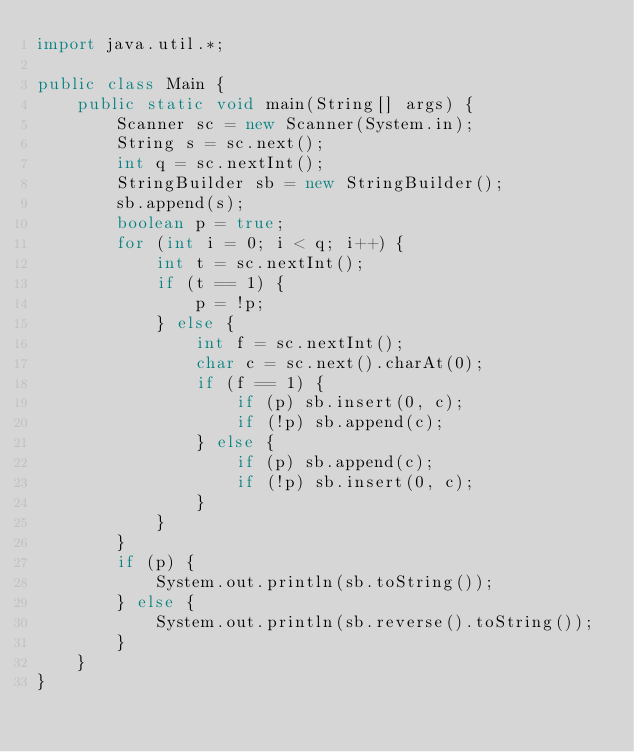<code> <loc_0><loc_0><loc_500><loc_500><_Java_>import java.util.*;

public class Main {
    public static void main(String[] args) {
        Scanner sc = new Scanner(System.in);
        String s = sc.next();
        int q = sc.nextInt();
        StringBuilder sb = new StringBuilder();
        sb.append(s);
        boolean p = true;
        for (int i = 0; i < q; i++) {
            int t = sc.nextInt();
            if (t == 1) {
                p = !p;
            } else {
                int f = sc.nextInt();
                char c = sc.next().charAt(0);
                if (f == 1) {
                    if (p) sb.insert(0, c);
                    if (!p) sb.append(c);
                } else {
                    if (p) sb.append(c);
                    if (!p) sb.insert(0, c);
                }
            }
        }
        if (p) {
            System.out.println(sb.toString());
        } else {
            System.out.println(sb.reverse().toString());
        }
    }
}
</code> 